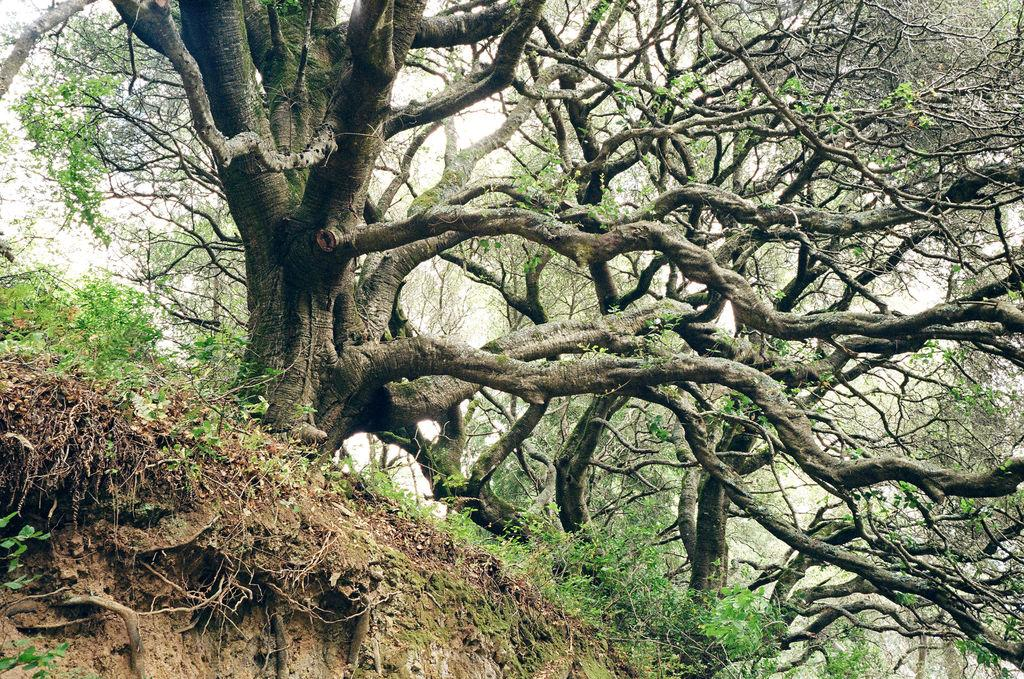What type of vegetation is present in the image? There are big trees in the image. Can you describe the ground on the left side of the image? There is soil visible on the left side of the image. What type of chicken is sitting on the machine in the image? There is no chicken or machine present in the image. 